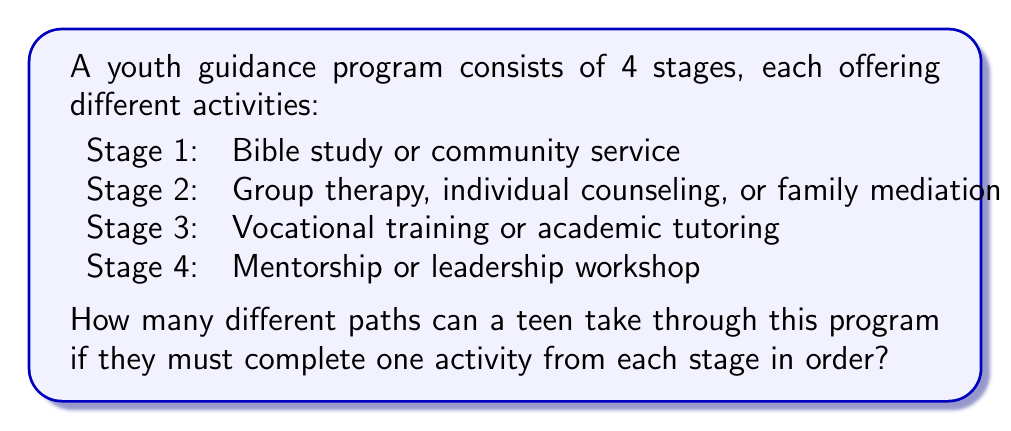What is the answer to this math problem? To solve this problem, we'll use the multiplication principle of counting. This principle states that if we have a sequence of independent choices, the total number of possible outcomes is the product of the number of options for each choice.

Let's break it down by stage:

1. Stage 1: 2 options (Bible study or community service)
2. Stage 2: 3 options (Group therapy, individual counseling, or family mediation)
3. Stage 3: 2 options (Vocational training or academic tutoring)
4. Stage 4: 2 options (Mentorship or leadership workshop)

Now, we multiply the number of options for each stage:

$$\text{Total paths} = 2 \times 3 \times 2 \times 2$$

Calculating this:

$$\text{Total paths} = 24$$

Therefore, there are 24 different paths a teen can take through this multi-step guidance program.

To visualize this, we can think of it as a tree diagram where each branch represents a choice, and following any path from root to leaf gives us one of the 24 possible combinations.
Answer: 24 paths 